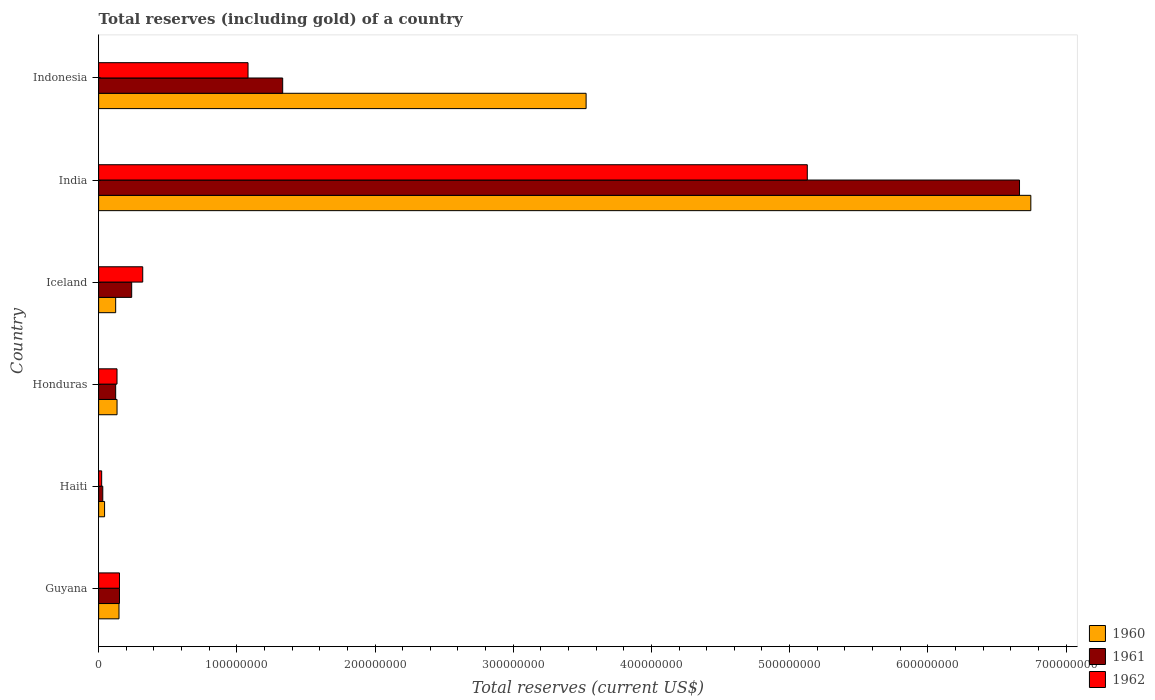How many different coloured bars are there?
Make the answer very short. 3. How many groups of bars are there?
Keep it short and to the point. 6. Are the number of bars on each tick of the Y-axis equal?
Make the answer very short. Yes. What is the total reserves (including gold) in 1960 in India?
Offer a very short reply. 6.75e+08. Across all countries, what is the maximum total reserves (including gold) in 1962?
Provide a short and direct response. 5.13e+08. Across all countries, what is the minimum total reserves (including gold) in 1962?
Make the answer very short. 2.20e+06. In which country was the total reserves (including gold) in 1961 minimum?
Keep it short and to the point. Haiti. What is the total total reserves (including gold) in 1961 in the graph?
Give a very brief answer. 8.54e+08. What is the difference between the total reserves (including gold) in 1961 in Haiti and that in Honduras?
Your answer should be compact. -9.33e+06. What is the difference between the total reserves (including gold) in 1961 in Guyana and the total reserves (including gold) in 1962 in Honduras?
Offer a very short reply. 1.79e+06. What is the average total reserves (including gold) in 1960 per country?
Your answer should be very brief. 1.79e+08. What is the difference between the total reserves (including gold) in 1962 and total reserves (including gold) in 1961 in Honduras?
Make the answer very short. 9.70e+05. What is the ratio of the total reserves (including gold) in 1961 in Honduras to that in India?
Offer a very short reply. 0.02. Is the difference between the total reserves (including gold) in 1962 in Honduras and India greater than the difference between the total reserves (including gold) in 1961 in Honduras and India?
Offer a very short reply. Yes. What is the difference between the highest and the second highest total reserves (including gold) in 1961?
Provide a short and direct response. 5.33e+08. What is the difference between the highest and the lowest total reserves (including gold) in 1962?
Ensure brevity in your answer.  5.11e+08. Is the sum of the total reserves (including gold) in 1961 in Honduras and Iceland greater than the maximum total reserves (including gold) in 1962 across all countries?
Provide a short and direct response. No. What does the 1st bar from the top in Haiti represents?
Provide a succinct answer. 1962. What does the 1st bar from the bottom in Haiti represents?
Keep it short and to the point. 1960. How many bars are there?
Offer a terse response. 18. Are all the bars in the graph horizontal?
Offer a terse response. Yes. Are the values on the major ticks of X-axis written in scientific E-notation?
Offer a terse response. No. Does the graph contain any zero values?
Your answer should be very brief. No. What is the title of the graph?
Provide a short and direct response. Total reserves (including gold) of a country. Does "2007" appear as one of the legend labels in the graph?
Provide a short and direct response. No. What is the label or title of the X-axis?
Keep it short and to the point. Total reserves (current US$). What is the label or title of the Y-axis?
Keep it short and to the point. Country. What is the Total reserves (current US$) of 1960 in Guyana?
Offer a very short reply. 1.47e+07. What is the Total reserves (current US$) in 1961 in Guyana?
Make the answer very short. 1.51e+07. What is the Total reserves (current US$) in 1962 in Guyana?
Ensure brevity in your answer.  1.51e+07. What is the Total reserves (current US$) of 1960 in Haiti?
Your response must be concise. 4.30e+06. What is the Total reserves (current US$) in 1961 in Haiti?
Offer a terse response. 3.00e+06. What is the Total reserves (current US$) of 1962 in Haiti?
Keep it short and to the point. 2.20e+06. What is the Total reserves (current US$) in 1960 in Honduras?
Your answer should be very brief. 1.33e+07. What is the Total reserves (current US$) of 1961 in Honduras?
Your answer should be very brief. 1.23e+07. What is the Total reserves (current US$) of 1962 in Honduras?
Offer a very short reply. 1.33e+07. What is the Total reserves (current US$) of 1960 in Iceland?
Provide a succinct answer. 1.23e+07. What is the Total reserves (current US$) in 1961 in Iceland?
Offer a terse response. 2.39e+07. What is the Total reserves (current US$) of 1962 in Iceland?
Keep it short and to the point. 3.19e+07. What is the Total reserves (current US$) of 1960 in India?
Give a very brief answer. 6.75e+08. What is the Total reserves (current US$) of 1961 in India?
Your response must be concise. 6.66e+08. What is the Total reserves (current US$) of 1962 in India?
Keep it short and to the point. 5.13e+08. What is the Total reserves (current US$) in 1960 in Indonesia?
Provide a succinct answer. 3.53e+08. What is the Total reserves (current US$) in 1961 in Indonesia?
Keep it short and to the point. 1.33e+08. What is the Total reserves (current US$) of 1962 in Indonesia?
Offer a very short reply. 1.08e+08. Across all countries, what is the maximum Total reserves (current US$) in 1960?
Your answer should be compact. 6.75e+08. Across all countries, what is the maximum Total reserves (current US$) in 1961?
Give a very brief answer. 6.66e+08. Across all countries, what is the maximum Total reserves (current US$) of 1962?
Offer a very short reply. 5.13e+08. Across all countries, what is the minimum Total reserves (current US$) in 1960?
Give a very brief answer. 4.30e+06. Across all countries, what is the minimum Total reserves (current US$) of 1961?
Make the answer very short. 3.00e+06. Across all countries, what is the minimum Total reserves (current US$) of 1962?
Give a very brief answer. 2.20e+06. What is the total Total reserves (current US$) in 1960 in the graph?
Offer a terse response. 1.07e+09. What is the total Total reserves (current US$) of 1961 in the graph?
Offer a very short reply. 8.54e+08. What is the total Total reserves (current US$) in 1962 in the graph?
Offer a terse response. 6.83e+08. What is the difference between the Total reserves (current US$) in 1960 in Guyana and that in Haiti?
Your response must be concise. 1.04e+07. What is the difference between the Total reserves (current US$) of 1961 in Guyana and that in Haiti?
Keep it short and to the point. 1.21e+07. What is the difference between the Total reserves (current US$) of 1962 in Guyana and that in Haiti?
Provide a short and direct response. 1.29e+07. What is the difference between the Total reserves (current US$) of 1960 in Guyana and that in Honduras?
Your answer should be compact. 1.42e+06. What is the difference between the Total reserves (current US$) in 1961 in Guyana and that in Honduras?
Make the answer very short. 2.76e+06. What is the difference between the Total reserves (current US$) of 1962 in Guyana and that in Honduras?
Keep it short and to the point. 1.79e+06. What is the difference between the Total reserves (current US$) of 1960 in Guyana and that in Iceland?
Your answer should be very brief. 2.41e+06. What is the difference between the Total reserves (current US$) of 1961 in Guyana and that in Iceland?
Make the answer very short. -8.83e+06. What is the difference between the Total reserves (current US$) of 1962 in Guyana and that in Iceland?
Give a very brief answer. -1.68e+07. What is the difference between the Total reserves (current US$) in 1960 in Guyana and that in India?
Ensure brevity in your answer.  -6.60e+08. What is the difference between the Total reserves (current US$) in 1961 in Guyana and that in India?
Keep it short and to the point. -6.51e+08. What is the difference between the Total reserves (current US$) of 1962 in Guyana and that in India?
Give a very brief answer. -4.98e+08. What is the difference between the Total reserves (current US$) in 1960 in Guyana and that in Indonesia?
Provide a succinct answer. -3.38e+08. What is the difference between the Total reserves (current US$) of 1961 in Guyana and that in Indonesia?
Your response must be concise. -1.18e+08. What is the difference between the Total reserves (current US$) of 1962 in Guyana and that in Indonesia?
Your answer should be very brief. -9.30e+07. What is the difference between the Total reserves (current US$) in 1960 in Haiti and that in Honduras?
Your response must be concise. -9.02e+06. What is the difference between the Total reserves (current US$) in 1961 in Haiti and that in Honduras?
Offer a terse response. -9.33e+06. What is the difference between the Total reserves (current US$) in 1962 in Haiti and that in Honduras?
Your answer should be very brief. -1.11e+07. What is the difference between the Total reserves (current US$) in 1960 in Haiti and that in Iceland?
Keep it short and to the point. -8.03e+06. What is the difference between the Total reserves (current US$) of 1961 in Haiti and that in Iceland?
Your response must be concise. -2.09e+07. What is the difference between the Total reserves (current US$) in 1962 in Haiti and that in Iceland?
Your answer should be very brief. -2.97e+07. What is the difference between the Total reserves (current US$) in 1960 in Haiti and that in India?
Provide a succinct answer. -6.70e+08. What is the difference between the Total reserves (current US$) of 1961 in Haiti and that in India?
Your response must be concise. -6.63e+08. What is the difference between the Total reserves (current US$) in 1962 in Haiti and that in India?
Offer a terse response. -5.11e+08. What is the difference between the Total reserves (current US$) in 1960 in Haiti and that in Indonesia?
Provide a succinct answer. -3.48e+08. What is the difference between the Total reserves (current US$) in 1961 in Haiti and that in Indonesia?
Provide a short and direct response. -1.30e+08. What is the difference between the Total reserves (current US$) of 1962 in Haiti and that in Indonesia?
Keep it short and to the point. -1.06e+08. What is the difference between the Total reserves (current US$) of 1960 in Honduras and that in Iceland?
Your answer should be very brief. 9.88e+05. What is the difference between the Total reserves (current US$) in 1961 in Honduras and that in Iceland?
Offer a terse response. -1.16e+07. What is the difference between the Total reserves (current US$) in 1962 in Honduras and that in Iceland?
Your answer should be very brief. -1.86e+07. What is the difference between the Total reserves (current US$) in 1960 in Honduras and that in India?
Provide a short and direct response. -6.61e+08. What is the difference between the Total reserves (current US$) of 1961 in Honduras and that in India?
Make the answer very short. -6.54e+08. What is the difference between the Total reserves (current US$) in 1962 in Honduras and that in India?
Offer a very short reply. -4.99e+08. What is the difference between the Total reserves (current US$) in 1960 in Honduras and that in Indonesia?
Provide a succinct answer. -3.39e+08. What is the difference between the Total reserves (current US$) of 1961 in Honduras and that in Indonesia?
Ensure brevity in your answer.  -1.21e+08. What is the difference between the Total reserves (current US$) of 1962 in Honduras and that in Indonesia?
Your answer should be compact. -9.48e+07. What is the difference between the Total reserves (current US$) of 1960 in Iceland and that in India?
Ensure brevity in your answer.  -6.62e+08. What is the difference between the Total reserves (current US$) in 1961 in Iceland and that in India?
Provide a short and direct response. -6.42e+08. What is the difference between the Total reserves (current US$) in 1962 in Iceland and that in India?
Keep it short and to the point. -4.81e+08. What is the difference between the Total reserves (current US$) of 1960 in Iceland and that in Indonesia?
Your answer should be compact. -3.40e+08. What is the difference between the Total reserves (current US$) in 1961 in Iceland and that in Indonesia?
Offer a very short reply. -1.09e+08. What is the difference between the Total reserves (current US$) of 1962 in Iceland and that in Indonesia?
Make the answer very short. -7.62e+07. What is the difference between the Total reserves (current US$) in 1960 in India and that in Indonesia?
Make the answer very short. 3.22e+08. What is the difference between the Total reserves (current US$) of 1961 in India and that in Indonesia?
Your answer should be compact. 5.33e+08. What is the difference between the Total reserves (current US$) of 1962 in India and that in Indonesia?
Your response must be concise. 4.05e+08. What is the difference between the Total reserves (current US$) in 1960 in Guyana and the Total reserves (current US$) in 1961 in Haiti?
Keep it short and to the point. 1.17e+07. What is the difference between the Total reserves (current US$) of 1960 in Guyana and the Total reserves (current US$) of 1962 in Haiti?
Offer a terse response. 1.25e+07. What is the difference between the Total reserves (current US$) in 1961 in Guyana and the Total reserves (current US$) in 1962 in Haiti?
Your answer should be compact. 1.29e+07. What is the difference between the Total reserves (current US$) in 1960 in Guyana and the Total reserves (current US$) in 1961 in Honduras?
Give a very brief answer. 2.41e+06. What is the difference between the Total reserves (current US$) of 1960 in Guyana and the Total reserves (current US$) of 1962 in Honduras?
Ensure brevity in your answer.  1.44e+06. What is the difference between the Total reserves (current US$) in 1961 in Guyana and the Total reserves (current US$) in 1962 in Honduras?
Provide a short and direct response. 1.79e+06. What is the difference between the Total reserves (current US$) in 1960 in Guyana and the Total reserves (current US$) in 1961 in Iceland?
Provide a succinct answer. -9.18e+06. What is the difference between the Total reserves (current US$) of 1960 in Guyana and the Total reserves (current US$) of 1962 in Iceland?
Make the answer very short. -1.72e+07. What is the difference between the Total reserves (current US$) of 1961 in Guyana and the Total reserves (current US$) of 1962 in Iceland?
Offer a very short reply. -1.68e+07. What is the difference between the Total reserves (current US$) in 1960 in Guyana and the Total reserves (current US$) in 1961 in India?
Ensure brevity in your answer.  -6.52e+08. What is the difference between the Total reserves (current US$) in 1960 in Guyana and the Total reserves (current US$) in 1962 in India?
Provide a short and direct response. -4.98e+08. What is the difference between the Total reserves (current US$) in 1961 in Guyana and the Total reserves (current US$) in 1962 in India?
Your answer should be compact. -4.98e+08. What is the difference between the Total reserves (current US$) in 1960 in Guyana and the Total reserves (current US$) in 1961 in Indonesia?
Your response must be concise. -1.18e+08. What is the difference between the Total reserves (current US$) in 1960 in Guyana and the Total reserves (current US$) in 1962 in Indonesia?
Provide a succinct answer. -9.34e+07. What is the difference between the Total reserves (current US$) in 1961 in Guyana and the Total reserves (current US$) in 1962 in Indonesia?
Your answer should be very brief. -9.30e+07. What is the difference between the Total reserves (current US$) in 1960 in Haiti and the Total reserves (current US$) in 1961 in Honduras?
Provide a short and direct response. -8.03e+06. What is the difference between the Total reserves (current US$) of 1960 in Haiti and the Total reserves (current US$) of 1962 in Honduras?
Make the answer very short. -9.00e+06. What is the difference between the Total reserves (current US$) of 1961 in Haiti and the Total reserves (current US$) of 1962 in Honduras?
Keep it short and to the point. -1.03e+07. What is the difference between the Total reserves (current US$) of 1960 in Haiti and the Total reserves (current US$) of 1961 in Iceland?
Your answer should be very brief. -1.96e+07. What is the difference between the Total reserves (current US$) of 1960 in Haiti and the Total reserves (current US$) of 1962 in Iceland?
Provide a succinct answer. -2.76e+07. What is the difference between the Total reserves (current US$) of 1961 in Haiti and the Total reserves (current US$) of 1962 in Iceland?
Make the answer very short. -2.89e+07. What is the difference between the Total reserves (current US$) of 1960 in Haiti and the Total reserves (current US$) of 1961 in India?
Provide a short and direct response. -6.62e+08. What is the difference between the Total reserves (current US$) in 1960 in Haiti and the Total reserves (current US$) in 1962 in India?
Offer a very short reply. -5.08e+08. What is the difference between the Total reserves (current US$) of 1961 in Haiti and the Total reserves (current US$) of 1962 in India?
Provide a short and direct response. -5.10e+08. What is the difference between the Total reserves (current US$) in 1960 in Haiti and the Total reserves (current US$) in 1961 in Indonesia?
Give a very brief answer. -1.29e+08. What is the difference between the Total reserves (current US$) in 1960 in Haiti and the Total reserves (current US$) in 1962 in Indonesia?
Your answer should be compact. -1.04e+08. What is the difference between the Total reserves (current US$) in 1961 in Haiti and the Total reserves (current US$) in 1962 in Indonesia?
Provide a short and direct response. -1.05e+08. What is the difference between the Total reserves (current US$) in 1960 in Honduras and the Total reserves (current US$) in 1961 in Iceland?
Provide a succinct answer. -1.06e+07. What is the difference between the Total reserves (current US$) of 1960 in Honduras and the Total reserves (current US$) of 1962 in Iceland?
Ensure brevity in your answer.  -1.86e+07. What is the difference between the Total reserves (current US$) in 1961 in Honduras and the Total reserves (current US$) in 1962 in Iceland?
Offer a very short reply. -1.96e+07. What is the difference between the Total reserves (current US$) of 1960 in Honduras and the Total reserves (current US$) of 1961 in India?
Offer a very short reply. -6.53e+08. What is the difference between the Total reserves (current US$) in 1960 in Honduras and the Total reserves (current US$) in 1962 in India?
Provide a succinct answer. -4.99e+08. What is the difference between the Total reserves (current US$) in 1961 in Honduras and the Total reserves (current US$) in 1962 in India?
Provide a short and direct response. -5.00e+08. What is the difference between the Total reserves (current US$) of 1960 in Honduras and the Total reserves (current US$) of 1961 in Indonesia?
Make the answer very short. -1.20e+08. What is the difference between the Total reserves (current US$) of 1960 in Honduras and the Total reserves (current US$) of 1962 in Indonesia?
Provide a succinct answer. -9.48e+07. What is the difference between the Total reserves (current US$) of 1961 in Honduras and the Total reserves (current US$) of 1962 in Indonesia?
Your answer should be compact. -9.58e+07. What is the difference between the Total reserves (current US$) in 1960 in Iceland and the Total reserves (current US$) in 1961 in India?
Your answer should be very brief. -6.54e+08. What is the difference between the Total reserves (current US$) of 1960 in Iceland and the Total reserves (current US$) of 1962 in India?
Keep it short and to the point. -5.00e+08. What is the difference between the Total reserves (current US$) in 1961 in Iceland and the Total reserves (current US$) in 1962 in India?
Your response must be concise. -4.89e+08. What is the difference between the Total reserves (current US$) of 1960 in Iceland and the Total reserves (current US$) of 1961 in Indonesia?
Provide a succinct answer. -1.21e+08. What is the difference between the Total reserves (current US$) in 1960 in Iceland and the Total reserves (current US$) in 1962 in Indonesia?
Provide a short and direct response. -9.58e+07. What is the difference between the Total reserves (current US$) of 1961 in Iceland and the Total reserves (current US$) of 1962 in Indonesia?
Your answer should be compact. -8.42e+07. What is the difference between the Total reserves (current US$) of 1960 in India and the Total reserves (current US$) of 1961 in Indonesia?
Your answer should be compact. 5.41e+08. What is the difference between the Total reserves (current US$) in 1960 in India and the Total reserves (current US$) in 1962 in Indonesia?
Keep it short and to the point. 5.66e+08. What is the difference between the Total reserves (current US$) of 1961 in India and the Total reserves (current US$) of 1962 in Indonesia?
Offer a terse response. 5.58e+08. What is the average Total reserves (current US$) of 1960 per country?
Ensure brevity in your answer.  1.79e+08. What is the average Total reserves (current US$) in 1961 per country?
Make the answer very short. 1.42e+08. What is the average Total reserves (current US$) in 1962 per country?
Provide a succinct answer. 1.14e+08. What is the difference between the Total reserves (current US$) of 1960 and Total reserves (current US$) of 1961 in Guyana?
Your answer should be very brief. -3.50e+05. What is the difference between the Total reserves (current US$) of 1960 and Total reserves (current US$) of 1962 in Guyana?
Provide a succinct answer. -3.50e+05. What is the difference between the Total reserves (current US$) in 1960 and Total reserves (current US$) in 1961 in Haiti?
Give a very brief answer. 1.30e+06. What is the difference between the Total reserves (current US$) in 1960 and Total reserves (current US$) in 1962 in Haiti?
Your answer should be compact. 2.10e+06. What is the difference between the Total reserves (current US$) of 1960 and Total reserves (current US$) of 1961 in Honduras?
Your answer should be compact. 9.91e+05. What is the difference between the Total reserves (current US$) in 1960 and Total reserves (current US$) in 1962 in Honduras?
Keep it short and to the point. 2.16e+04. What is the difference between the Total reserves (current US$) of 1961 and Total reserves (current US$) of 1962 in Honduras?
Offer a terse response. -9.70e+05. What is the difference between the Total reserves (current US$) of 1960 and Total reserves (current US$) of 1961 in Iceland?
Offer a terse response. -1.16e+07. What is the difference between the Total reserves (current US$) of 1960 and Total reserves (current US$) of 1962 in Iceland?
Give a very brief answer. -1.96e+07. What is the difference between the Total reserves (current US$) in 1961 and Total reserves (current US$) in 1962 in Iceland?
Make the answer very short. -8.00e+06. What is the difference between the Total reserves (current US$) of 1960 and Total reserves (current US$) of 1961 in India?
Offer a very short reply. 8.18e+06. What is the difference between the Total reserves (current US$) in 1960 and Total reserves (current US$) in 1962 in India?
Give a very brief answer. 1.62e+08. What is the difference between the Total reserves (current US$) of 1961 and Total reserves (current US$) of 1962 in India?
Give a very brief answer. 1.54e+08. What is the difference between the Total reserves (current US$) in 1960 and Total reserves (current US$) in 1961 in Indonesia?
Ensure brevity in your answer.  2.20e+08. What is the difference between the Total reserves (current US$) in 1960 and Total reserves (current US$) in 1962 in Indonesia?
Your answer should be very brief. 2.45e+08. What is the difference between the Total reserves (current US$) in 1961 and Total reserves (current US$) in 1962 in Indonesia?
Offer a very short reply. 2.51e+07. What is the ratio of the Total reserves (current US$) in 1960 in Guyana to that in Haiti?
Provide a succinct answer. 3.43. What is the ratio of the Total reserves (current US$) of 1961 in Guyana to that in Haiti?
Make the answer very short. 5.03. What is the ratio of the Total reserves (current US$) of 1962 in Guyana to that in Haiti?
Make the answer very short. 6.86. What is the ratio of the Total reserves (current US$) in 1960 in Guyana to that in Honduras?
Offer a very short reply. 1.11. What is the ratio of the Total reserves (current US$) in 1961 in Guyana to that in Honduras?
Give a very brief answer. 1.22. What is the ratio of the Total reserves (current US$) in 1962 in Guyana to that in Honduras?
Your response must be concise. 1.13. What is the ratio of the Total reserves (current US$) of 1960 in Guyana to that in Iceland?
Provide a succinct answer. 1.2. What is the ratio of the Total reserves (current US$) in 1961 in Guyana to that in Iceland?
Your answer should be very brief. 0.63. What is the ratio of the Total reserves (current US$) of 1962 in Guyana to that in Iceland?
Keep it short and to the point. 0.47. What is the ratio of the Total reserves (current US$) of 1960 in Guyana to that in India?
Your answer should be compact. 0.02. What is the ratio of the Total reserves (current US$) in 1961 in Guyana to that in India?
Your response must be concise. 0.02. What is the ratio of the Total reserves (current US$) of 1962 in Guyana to that in India?
Your answer should be very brief. 0.03. What is the ratio of the Total reserves (current US$) of 1960 in Guyana to that in Indonesia?
Offer a very short reply. 0.04. What is the ratio of the Total reserves (current US$) of 1961 in Guyana to that in Indonesia?
Give a very brief answer. 0.11. What is the ratio of the Total reserves (current US$) of 1962 in Guyana to that in Indonesia?
Ensure brevity in your answer.  0.14. What is the ratio of the Total reserves (current US$) in 1960 in Haiti to that in Honduras?
Offer a terse response. 0.32. What is the ratio of the Total reserves (current US$) of 1961 in Haiti to that in Honduras?
Ensure brevity in your answer.  0.24. What is the ratio of the Total reserves (current US$) of 1962 in Haiti to that in Honduras?
Provide a short and direct response. 0.17. What is the ratio of the Total reserves (current US$) in 1960 in Haiti to that in Iceland?
Give a very brief answer. 0.35. What is the ratio of the Total reserves (current US$) of 1961 in Haiti to that in Iceland?
Offer a terse response. 0.13. What is the ratio of the Total reserves (current US$) in 1962 in Haiti to that in Iceland?
Make the answer very short. 0.07. What is the ratio of the Total reserves (current US$) of 1960 in Haiti to that in India?
Offer a terse response. 0.01. What is the ratio of the Total reserves (current US$) of 1961 in Haiti to that in India?
Offer a very short reply. 0. What is the ratio of the Total reserves (current US$) in 1962 in Haiti to that in India?
Offer a very short reply. 0. What is the ratio of the Total reserves (current US$) in 1960 in Haiti to that in Indonesia?
Give a very brief answer. 0.01. What is the ratio of the Total reserves (current US$) in 1961 in Haiti to that in Indonesia?
Make the answer very short. 0.02. What is the ratio of the Total reserves (current US$) in 1962 in Haiti to that in Indonesia?
Offer a very short reply. 0.02. What is the ratio of the Total reserves (current US$) in 1960 in Honduras to that in Iceland?
Your response must be concise. 1.08. What is the ratio of the Total reserves (current US$) of 1961 in Honduras to that in Iceland?
Make the answer very short. 0.52. What is the ratio of the Total reserves (current US$) in 1962 in Honduras to that in Iceland?
Offer a very short reply. 0.42. What is the ratio of the Total reserves (current US$) in 1960 in Honduras to that in India?
Provide a short and direct response. 0.02. What is the ratio of the Total reserves (current US$) of 1961 in Honduras to that in India?
Keep it short and to the point. 0.02. What is the ratio of the Total reserves (current US$) of 1962 in Honduras to that in India?
Keep it short and to the point. 0.03. What is the ratio of the Total reserves (current US$) of 1960 in Honduras to that in Indonesia?
Your answer should be compact. 0.04. What is the ratio of the Total reserves (current US$) in 1961 in Honduras to that in Indonesia?
Give a very brief answer. 0.09. What is the ratio of the Total reserves (current US$) in 1962 in Honduras to that in Indonesia?
Give a very brief answer. 0.12. What is the ratio of the Total reserves (current US$) in 1960 in Iceland to that in India?
Provide a short and direct response. 0.02. What is the ratio of the Total reserves (current US$) in 1961 in Iceland to that in India?
Offer a very short reply. 0.04. What is the ratio of the Total reserves (current US$) in 1962 in Iceland to that in India?
Your answer should be compact. 0.06. What is the ratio of the Total reserves (current US$) in 1960 in Iceland to that in Indonesia?
Ensure brevity in your answer.  0.04. What is the ratio of the Total reserves (current US$) in 1961 in Iceland to that in Indonesia?
Your answer should be compact. 0.18. What is the ratio of the Total reserves (current US$) in 1962 in Iceland to that in Indonesia?
Ensure brevity in your answer.  0.3. What is the ratio of the Total reserves (current US$) in 1960 in India to that in Indonesia?
Your answer should be very brief. 1.91. What is the ratio of the Total reserves (current US$) of 1961 in India to that in Indonesia?
Give a very brief answer. 5. What is the ratio of the Total reserves (current US$) in 1962 in India to that in Indonesia?
Your response must be concise. 4.74. What is the difference between the highest and the second highest Total reserves (current US$) in 1960?
Your answer should be compact. 3.22e+08. What is the difference between the highest and the second highest Total reserves (current US$) in 1961?
Keep it short and to the point. 5.33e+08. What is the difference between the highest and the second highest Total reserves (current US$) of 1962?
Provide a succinct answer. 4.05e+08. What is the difference between the highest and the lowest Total reserves (current US$) in 1960?
Your answer should be compact. 6.70e+08. What is the difference between the highest and the lowest Total reserves (current US$) of 1961?
Provide a short and direct response. 6.63e+08. What is the difference between the highest and the lowest Total reserves (current US$) in 1962?
Provide a short and direct response. 5.11e+08. 